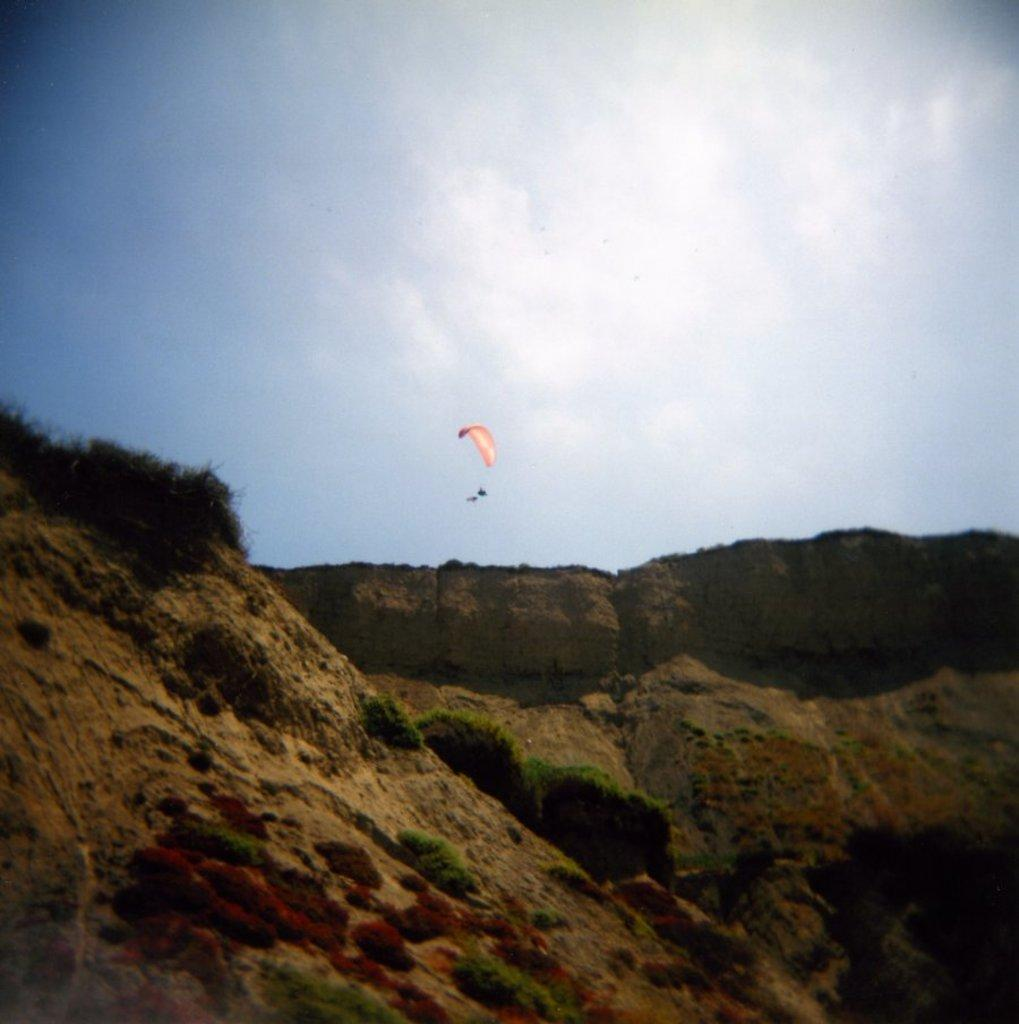What is the main object in the center of the image? There is a parachute in the center of the image. What can be seen at the bottom of the image? There are rocks at the bottom of the image. What is visible in the background of the image? The sky is visible in the background of the image. How many cacti can be seen in the image? There are no cacti present in the image. Is the camera visible in the image? There is no camera present in the image. 